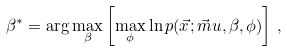Convert formula to latex. <formula><loc_0><loc_0><loc_500><loc_500>\beta ^ { * } = \arg \max _ { \beta } \left [ \max _ { \phi } \ln p ( \vec { x } ; \vec { m } u , \beta , \phi ) \right ] \, ,</formula> 